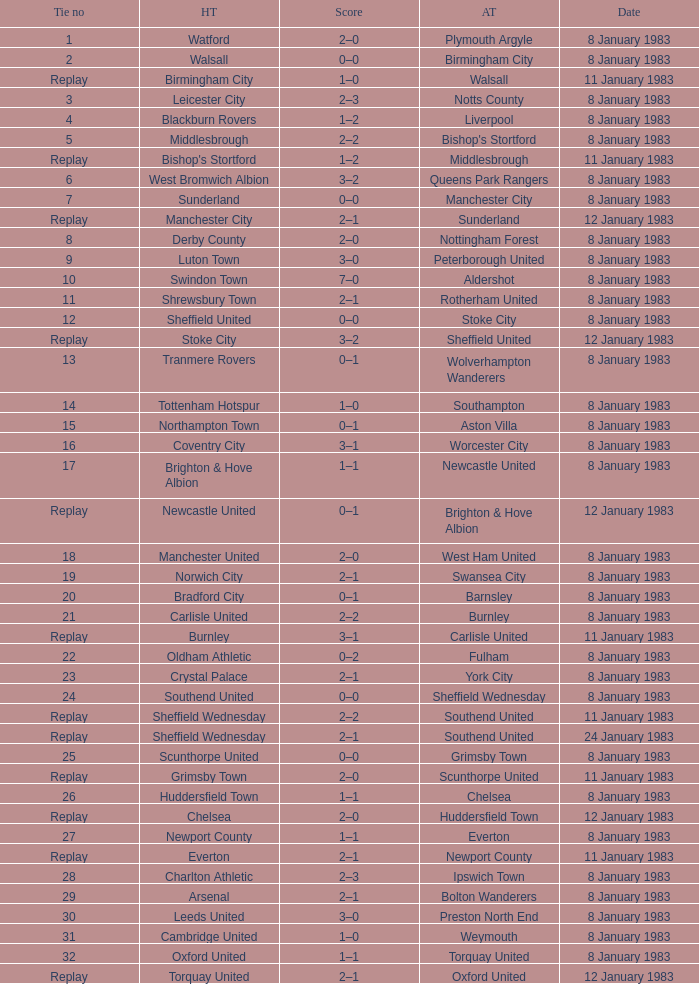Could you parse the entire table? {'header': ['Tie no', 'HT', 'Score', 'AT', 'Date'], 'rows': [['1', 'Watford', '2–0', 'Plymouth Argyle', '8 January 1983'], ['2', 'Walsall', '0–0', 'Birmingham City', '8 January 1983'], ['Replay', 'Birmingham City', '1–0', 'Walsall', '11 January 1983'], ['3', 'Leicester City', '2–3', 'Notts County', '8 January 1983'], ['4', 'Blackburn Rovers', '1–2', 'Liverpool', '8 January 1983'], ['5', 'Middlesbrough', '2–2', "Bishop's Stortford", '8 January 1983'], ['Replay', "Bishop's Stortford", '1–2', 'Middlesbrough', '11 January 1983'], ['6', 'West Bromwich Albion', '3–2', 'Queens Park Rangers', '8 January 1983'], ['7', 'Sunderland', '0–0', 'Manchester City', '8 January 1983'], ['Replay', 'Manchester City', '2–1', 'Sunderland', '12 January 1983'], ['8', 'Derby County', '2–0', 'Nottingham Forest', '8 January 1983'], ['9', 'Luton Town', '3–0', 'Peterborough United', '8 January 1983'], ['10', 'Swindon Town', '7–0', 'Aldershot', '8 January 1983'], ['11', 'Shrewsbury Town', '2–1', 'Rotherham United', '8 January 1983'], ['12', 'Sheffield United', '0–0', 'Stoke City', '8 January 1983'], ['Replay', 'Stoke City', '3–2', 'Sheffield United', '12 January 1983'], ['13', 'Tranmere Rovers', '0–1', 'Wolverhampton Wanderers', '8 January 1983'], ['14', 'Tottenham Hotspur', '1–0', 'Southampton', '8 January 1983'], ['15', 'Northampton Town', '0–1', 'Aston Villa', '8 January 1983'], ['16', 'Coventry City', '3–1', 'Worcester City', '8 January 1983'], ['17', 'Brighton & Hove Albion', '1–1', 'Newcastle United', '8 January 1983'], ['Replay', 'Newcastle United', '0–1', 'Brighton & Hove Albion', '12 January 1983'], ['18', 'Manchester United', '2–0', 'West Ham United', '8 January 1983'], ['19', 'Norwich City', '2–1', 'Swansea City', '8 January 1983'], ['20', 'Bradford City', '0–1', 'Barnsley', '8 January 1983'], ['21', 'Carlisle United', '2–2', 'Burnley', '8 January 1983'], ['Replay', 'Burnley', '3–1', 'Carlisle United', '11 January 1983'], ['22', 'Oldham Athletic', '0–2', 'Fulham', '8 January 1983'], ['23', 'Crystal Palace', '2–1', 'York City', '8 January 1983'], ['24', 'Southend United', '0–0', 'Sheffield Wednesday', '8 January 1983'], ['Replay', 'Sheffield Wednesday', '2–2', 'Southend United', '11 January 1983'], ['Replay', 'Sheffield Wednesday', '2–1', 'Southend United', '24 January 1983'], ['25', 'Scunthorpe United', '0–0', 'Grimsby Town', '8 January 1983'], ['Replay', 'Grimsby Town', '2–0', 'Scunthorpe United', '11 January 1983'], ['26', 'Huddersfield Town', '1–1', 'Chelsea', '8 January 1983'], ['Replay', 'Chelsea', '2–0', 'Huddersfield Town', '12 January 1983'], ['27', 'Newport County', '1–1', 'Everton', '8 January 1983'], ['Replay', 'Everton', '2–1', 'Newport County', '11 January 1983'], ['28', 'Charlton Athletic', '2–3', 'Ipswich Town', '8 January 1983'], ['29', 'Arsenal', '2–1', 'Bolton Wanderers', '8 January 1983'], ['30', 'Leeds United', '3–0', 'Preston North End', '8 January 1983'], ['31', 'Cambridge United', '1–0', 'Weymouth', '8 January 1983'], ['32', 'Oxford United', '1–1', 'Torquay United', '8 January 1983'], ['Replay', 'Torquay United', '2–1', 'Oxford United', '12 January 1983']]} In the tie where Southampton was the away team, who was the home team? Tottenham Hotspur. 